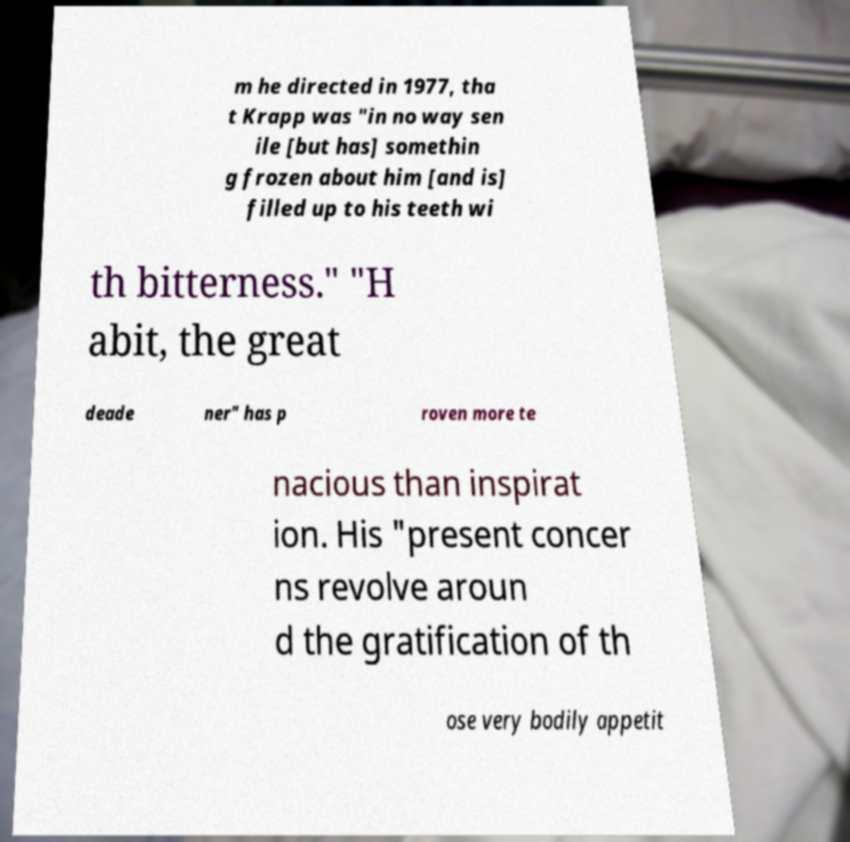What messages or text are displayed in this image? I need them in a readable, typed format. m he directed in 1977, tha t Krapp was "in no way sen ile [but has] somethin g frozen about him [and is] filled up to his teeth wi th bitterness." "H abit, the great deade ner" has p roven more te nacious than inspirat ion. His "present concer ns revolve aroun d the gratification of th ose very bodily appetit 